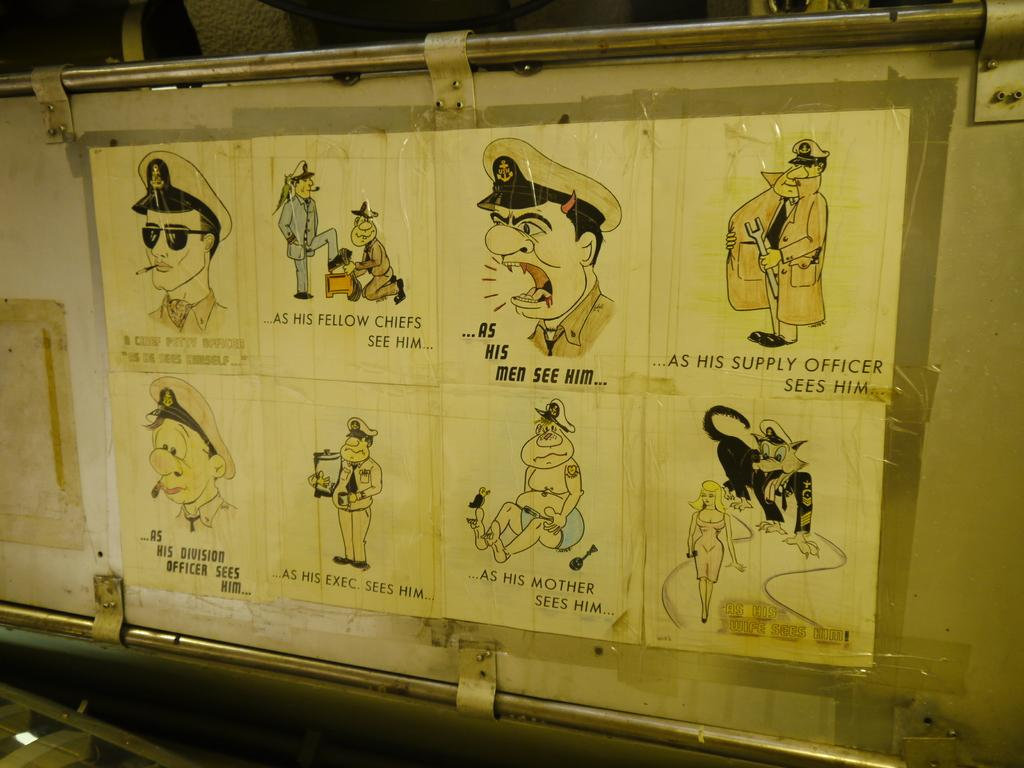What is present on the cardboard in the image? There is a poster on the cardboard in the image. How is the poster attached to the cardboard? The poster is pasted on the cardboard. What are the two rods used for in the image? The two rods on either side of the cardboard are likely used for support or display purposes. How many apples are hanging from the rods in the image? There are no apples present in the image; the rods are supporting the cardboard with the poster on it. What type of plant can be seen growing on the poster in the image? There is no plant visible on the poster in the image. 